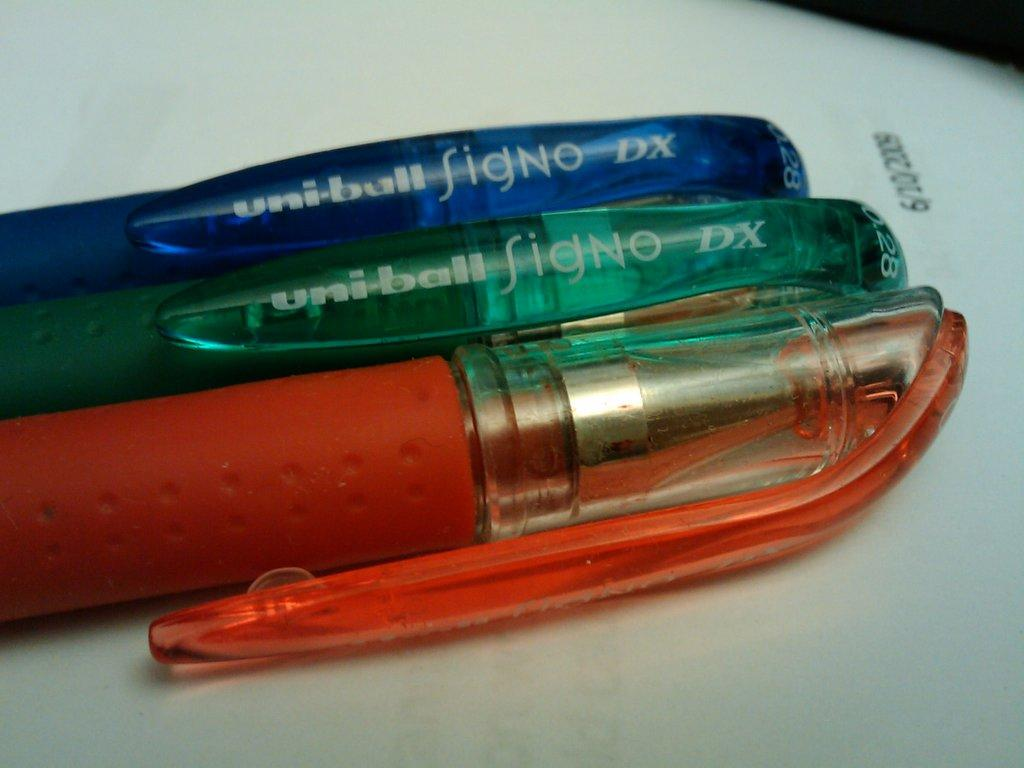What piece of furniture is present in the image? There is a table in the image. What items can be seen on the table? There are three pens on the table. Can you describe the colors of the pens? One pen is blue, another is green, and the third is red. What is located in the right corner of the image? There is an object in the right corner of the image. What is the color of the object? The object is black in color. What type of noise can be heard coming from the pens in the image? There is no noise coming from the pens in the image; they are stationary objects. 